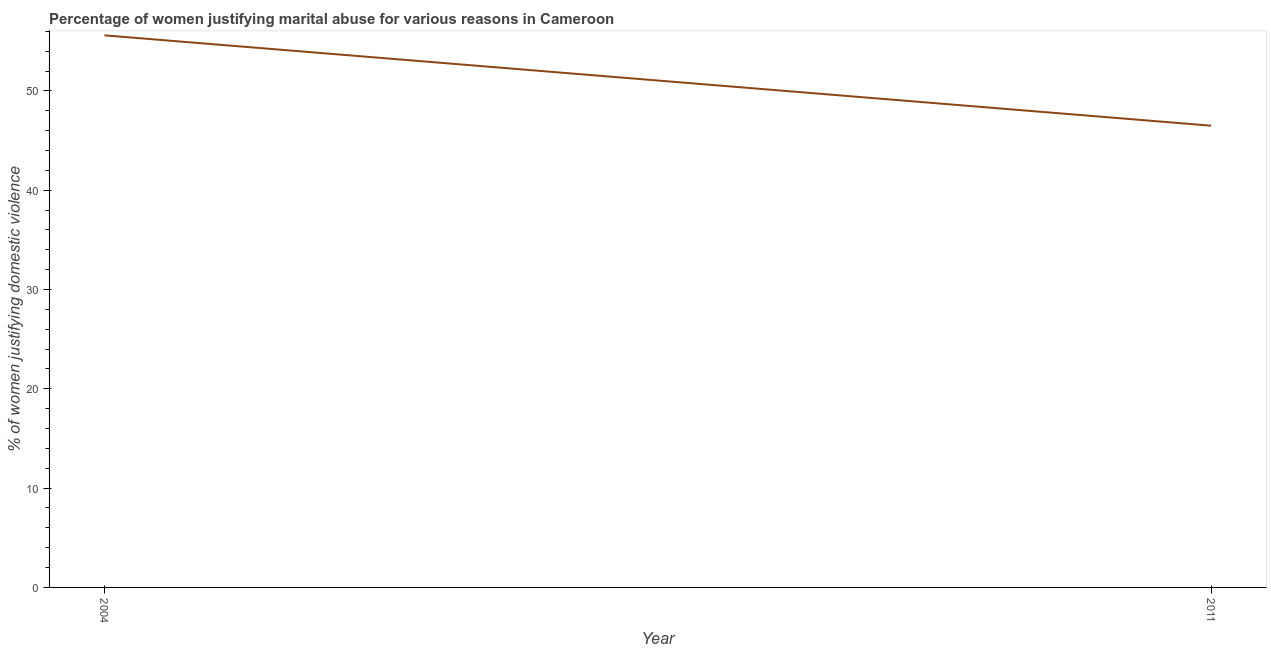What is the percentage of women justifying marital abuse in 2004?
Make the answer very short. 55.6. Across all years, what is the maximum percentage of women justifying marital abuse?
Offer a terse response. 55.6. Across all years, what is the minimum percentage of women justifying marital abuse?
Ensure brevity in your answer.  46.5. In which year was the percentage of women justifying marital abuse maximum?
Make the answer very short. 2004. What is the sum of the percentage of women justifying marital abuse?
Keep it short and to the point. 102.1. What is the difference between the percentage of women justifying marital abuse in 2004 and 2011?
Offer a terse response. 9.1. What is the average percentage of women justifying marital abuse per year?
Offer a terse response. 51.05. What is the median percentage of women justifying marital abuse?
Give a very brief answer. 51.05. What is the ratio of the percentage of women justifying marital abuse in 2004 to that in 2011?
Make the answer very short. 1.2. Is the percentage of women justifying marital abuse in 2004 less than that in 2011?
Keep it short and to the point. No. How many lines are there?
Ensure brevity in your answer.  1. What is the difference between two consecutive major ticks on the Y-axis?
Keep it short and to the point. 10. Does the graph contain any zero values?
Provide a short and direct response. No. Does the graph contain grids?
Your response must be concise. No. What is the title of the graph?
Your answer should be compact. Percentage of women justifying marital abuse for various reasons in Cameroon. What is the label or title of the Y-axis?
Provide a succinct answer. % of women justifying domestic violence. What is the % of women justifying domestic violence in 2004?
Provide a short and direct response. 55.6. What is the % of women justifying domestic violence of 2011?
Ensure brevity in your answer.  46.5. What is the difference between the % of women justifying domestic violence in 2004 and 2011?
Your response must be concise. 9.1. What is the ratio of the % of women justifying domestic violence in 2004 to that in 2011?
Ensure brevity in your answer.  1.2. 